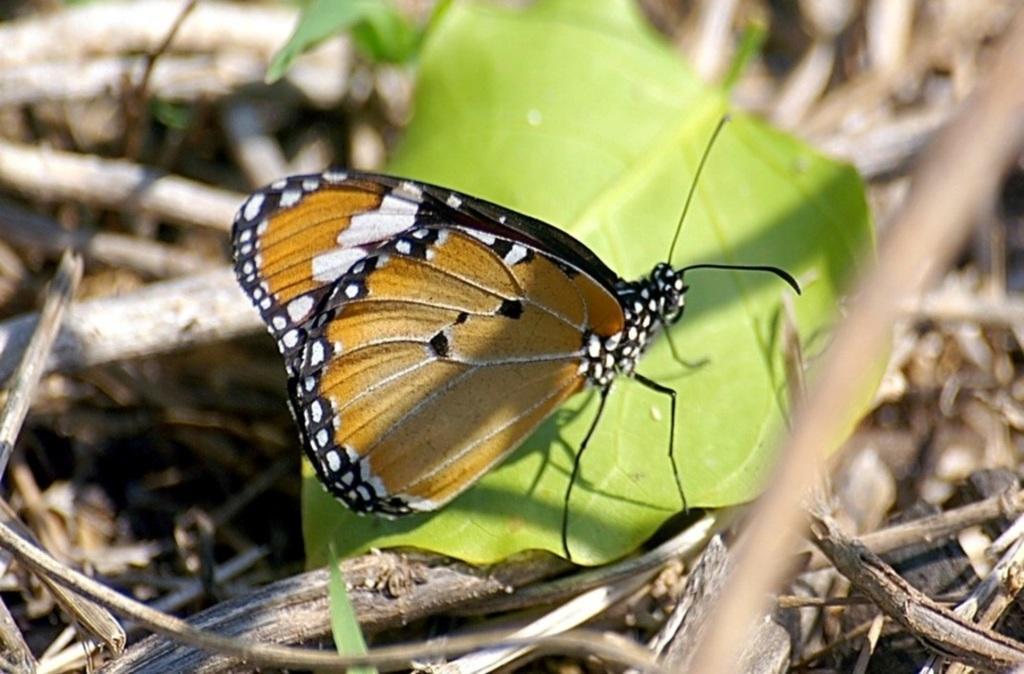In one or two sentences, can you explain what this image depicts? In this picture there is a butterfly on the leaf which is in the center. It is in brown, white and black in color. In the background there are dried plants. 